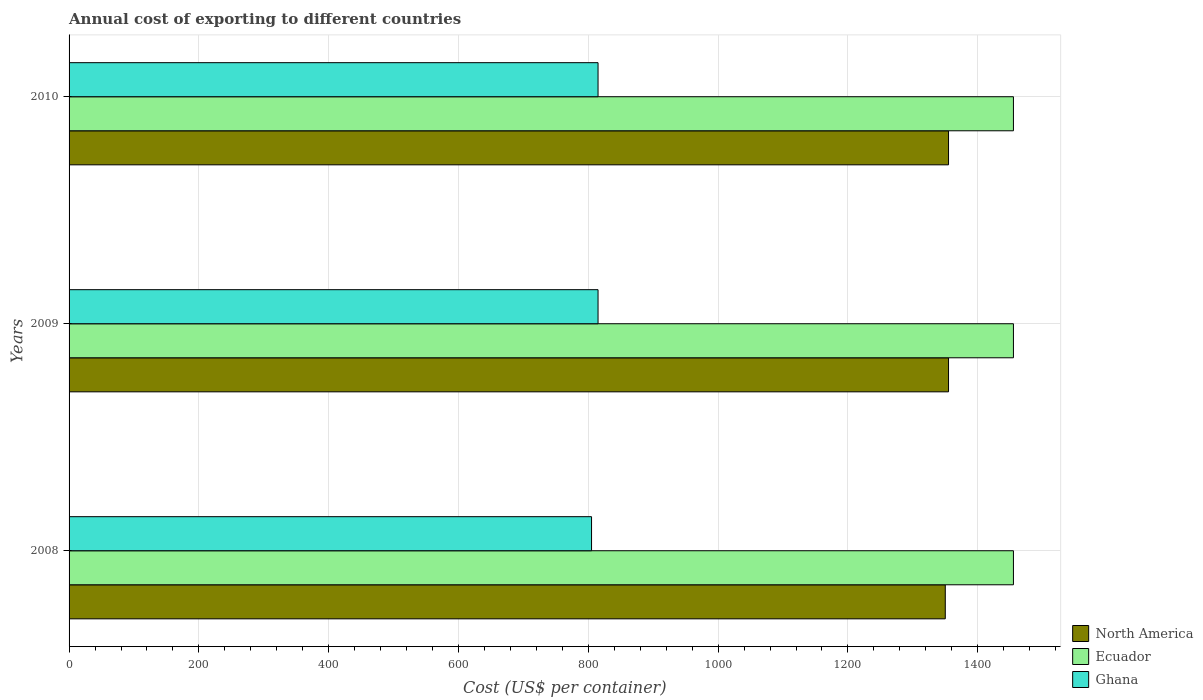How many different coloured bars are there?
Your answer should be very brief. 3. Are the number of bars on each tick of the Y-axis equal?
Provide a short and direct response. Yes. How many bars are there on the 1st tick from the bottom?
Provide a succinct answer. 3. In how many cases, is the number of bars for a given year not equal to the number of legend labels?
Your answer should be compact. 0. What is the total annual cost of exporting in North America in 2009?
Your response must be concise. 1355. Across all years, what is the maximum total annual cost of exporting in Ghana?
Your answer should be very brief. 815. Across all years, what is the minimum total annual cost of exporting in North America?
Keep it short and to the point. 1350. In which year was the total annual cost of exporting in Ecuador maximum?
Keep it short and to the point. 2008. What is the total total annual cost of exporting in North America in the graph?
Provide a short and direct response. 4060. What is the difference between the total annual cost of exporting in North America in 2009 and that in 2010?
Your answer should be compact. 0. What is the difference between the total annual cost of exporting in North America in 2010 and the total annual cost of exporting in Ecuador in 2008?
Your answer should be compact. -100. What is the average total annual cost of exporting in Ghana per year?
Ensure brevity in your answer.  811.67. In the year 2010, what is the difference between the total annual cost of exporting in Ecuador and total annual cost of exporting in Ghana?
Offer a terse response. 640. In how many years, is the total annual cost of exporting in North America greater than 80 US$?
Make the answer very short. 3. Is the total annual cost of exporting in North America in 2009 less than that in 2010?
Keep it short and to the point. No. What is the difference between the highest and the lowest total annual cost of exporting in Ecuador?
Offer a very short reply. 0. In how many years, is the total annual cost of exporting in Ghana greater than the average total annual cost of exporting in Ghana taken over all years?
Offer a terse response. 2. Is the sum of the total annual cost of exporting in Ghana in 2008 and 2009 greater than the maximum total annual cost of exporting in Ecuador across all years?
Provide a succinct answer. Yes. What does the 2nd bar from the top in 2009 represents?
Make the answer very short. Ecuador. What does the 3rd bar from the bottom in 2010 represents?
Keep it short and to the point. Ghana. Is it the case that in every year, the sum of the total annual cost of exporting in North America and total annual cost of exporting in Ecuador is greater than the total annual cost of exporting in Ghana?
Offer a very short reply. Yes. How many years are there in the graph?
Make the answer very short. 3. How are the legend labels stacked?
Provide a short and direct response. Vertical. What is the title of the graph?
Offer a very short reply. Annual cost of exporting to different countries. Does "Australia" appear as one of the legend labels in the graph?
Provide a succinct answer. No. What is the label or title of the X-axis?
Your answer should be compact. Cost (US$ per container). What is the label or title of the Y-axis?
Give a very brief answer. Years. What is the Cost (US$ per container) in North America in 2008?
Provide a succinct answer. 1350. What is the Cost (US$ per container) of Ecuador in 2008?
Ensure brevity in your answer.  1455. What is the Cost (US$ per container) in Ghana in 2008?
Give a very brief answer. 805. What is the Cost (US$ per container) of North America in 2009?
Your response must be concise. 1355. What is the Cost (US$ per container) in Ecuador in 2009?
Provide a short and direct response. 1455. What is the Cost (US$ per container) of Ghana in 2009?
Make the answer very short. 815. What is the Cost (US$ per container) in North America in 2010?
Your response must be concise. 1355. What is the Cost (US$ per container) in Ecuador in 2010?
Provide a short and direct response. 1455. What is the Cost (US$ per container) of Ghana in 2010?
Offer a terse response. 815. Across all years, what is the maximum Cost (US$ per container) in North America?
Your answer should be very brief. 1355. Across all years, what is the maximum Cost (US$ per container) in Ecuador?
Make the answer very short. 1455. Across all years, what is the maximum Cost (US$ per container) in Ghana?
Provide a succinct answer. 815. Across all years, what is the minimum Cost (US$ per container) in North America?
Provide a short and direct response. 1350. Across all years, what is the minimum Cost (US$ per container) of Ecuador?
Keep it short and to the point. 1455. Across all years, what is the minimum Cost (US$ per container) in Ghana?
Keep it short and to the point. 805. What is the total Cost (US$ per container) in North America in the graph?
Your response must be concise. 4060. What is the total Cost (US$ per container) in Ecuador in the graph?
Give a very brief answer. 4365. What is the total Cost (US$ per container) of Ghana in the graph?
Provide a succinct answer. 2435. What is the difference between the Cost (US$ per container) in North America in 2008 and that in 2009?
Your answer should be very brief. -5. What is the difference between the Cost (US$ per container) in North America in 2009 and that in 2010?
Offer a terse response. 0. What is the difference between the Cost (US$ per container) in Ecuador in 2009 and that in 2010?
Your answer should be compact. 0. What is the difference between the Cost (US$ per container) in Ghana in 2009 and that in 2010?
Ensure brevity in your answer.  0. What is the difference between the Cost (US$ per container) of North America in 2008 and the Cost (US$ per container) of Ecuador in 2009?
Offer a terse response. -105. What is the difference between the Cost (US$ per container) in North America in 2008 and the Cost (US$ per container) in Ghana in 2009?
Give a very brief answer. 535. What is the difference between the Cost (US$ per container) of Ecuador in 2008 and the Cost (US$ per container) of Ghana in 2009?
Provide a succinct answer. 640. What is the difference between the Cost (US$ per container) in North America in 2008 and the Cost (US$ per container) in Ecuador in 2010?
Give a very brief answer. -105. What is the difference between the Cost (US$ per container) of North America in 2008 and the Cost (US$ per container) of Ghana in 2010?
Your response must be concise. 535. What is the difference between the Cost (US$ per container) in Ecuador in 2008 and the Cost (US$ per container) in Ghana in 2010?
Give a very brief answer. 640. What is the difference between the Cost (US$ per container) in North America in 2009 and the Cost (US$ per container) in Ecuador in 2010?
Your answer should be very brief. -100. What is the difference between the Cost (US$ per container) in North America in 2009 and the Cost (US$ per container) in Ghana in 2010?
Your answer should be compact. 540. What is the difference between the Cost (US$ per container) of Ecuador in 2009 and the Cost (US$ per container) of Ghana in 2010?
Make the answer very short. 640. What is the average Cost (US$ per container) in North America per year?
Offer a terse response. 1353.33. What is the average Cost (US$ per container) of Ecuador per year?
Your answer should be very brief. 1455. What is the average Cost (US$ per container) of Ghana per year?
Offer a very short reply. 811.67. In the year 2008, what is the difference between the Cost (US$ per container) in North America and Cost (US$ per container) in Ecuador?
Provide a short and direct response. -105. In the year 2008, what is the difference between the Cost (US$ per container) of North America and Cost (US$ per container) of Ghana?
Give a very brief answer. 545. In the year 2008, what is the difference between the Cost (US$ per container) of Ecuador and Cost (US$ per container) of Ghana?
Your answer should be compact. 650. In the year 2009, what is the difference between the Cost (US$ per container) of North America and Cost (US$ per container) of Ecuador?
Provide a succinct answer. -100. In the year 2009, what is the difference between the Cost (US$ per container) of North America and Cost (US$ per container) of Ghana?
Give a very brief answer. 540. In the year 2009, what is the difference between the Cost (US$ per container) in Ecuador and Cost (US$ per container) in Ghana?
Keep it short and to the point. 640. In the year 2010, what is the difference between the Cost (US$ per container) of North America and Cost (US$ per container) of Ecuador?
Your answer should be compact. -100. In the year 2010, what is the difference between the Cost (US$ per container) of North America and Cost (US$ per container) of Ghana?
Ensure brevity in your answer.  540. In the year 2010, what is the difference between the Cost (US$ per container) of Ecuador and Cost (US$ per container) of Ghana?
Offer a terse response. 640. What is the ratio of the Cost (US$ per container) of Ecuador in 2008 to that in 2009?
Offer a terse response. 1. What is the ratio of the Cost (US$ per container) in Ghana in 2008 to that in 2009?
Make the answer very short. 0.99. What is the ratio of the Cost (US$ per container) in North America in 2008 to that in 2010?
Keep it short and to the point. 1. What is the ratio of the Cost (US$ per container) of Ecuador in 2008 to that in 2010?
Your answer should be very brief. 1. What is the ratio of the Cost (US$ per container) in Ghana in 2008 to that in 2010?
Ensure brevity in your answer.  0.99. What is the ratio of the Cost (US$ per container) of Ecuador in 2009 to that in 2010?
Keep it short and to the point. 1. What is the ratio of the Cost (US$ per container) in Ghana in 2009 to that in 2010?
Make the answer very short. 1. What is the difference between the highest and the second highest Cost (US$ per container) of North America?
Ensure brevity in your answer.  0. What is the difference between the highest and the second highest Cost (US$ per container) in Ecuador?
Give a very brief answer. 0. What is the difference between the highest and the second highest Cost (US$ per container) of Ghana?
Offer a terse response. 0. What is the difference between the highest and the lowest Cost (US$ per container) of Ecuador?
Provide a succinct answer. 0. 